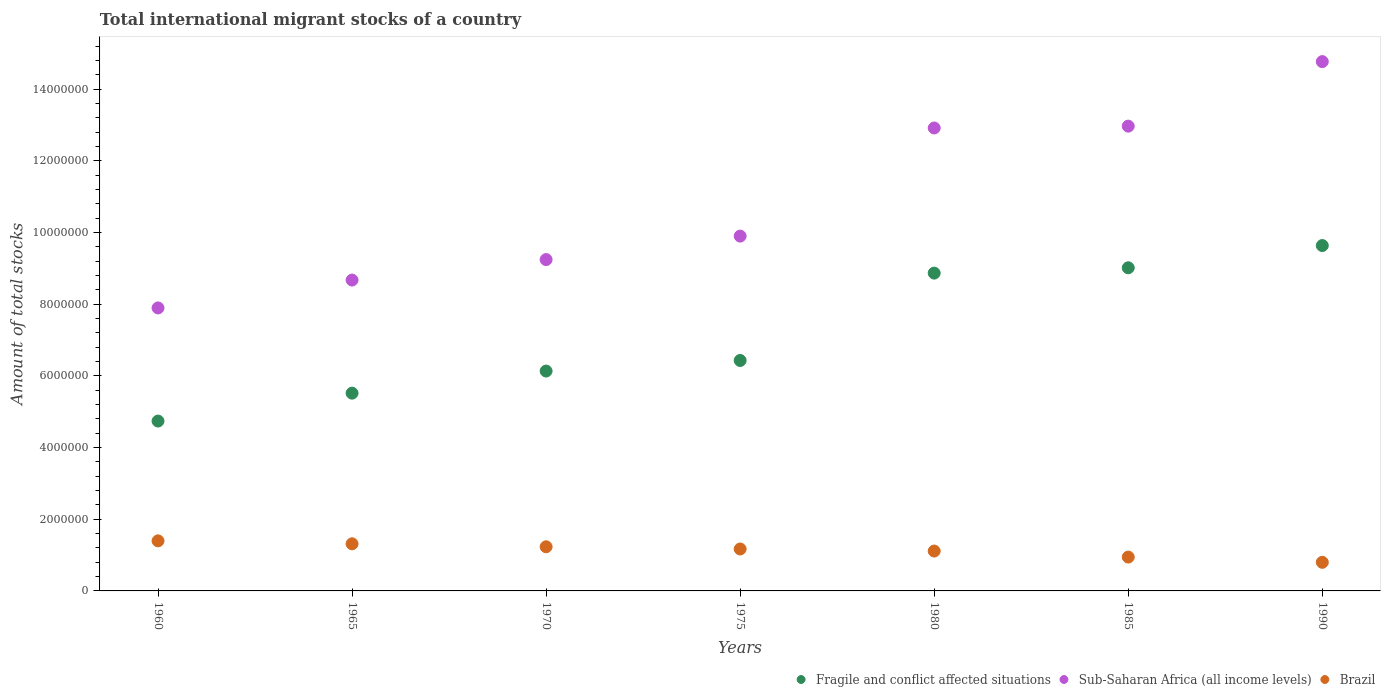How many different coloured dotlines are there?
Provide a short and direct response. 3. Is the number of dotlines equal to the number of legend labels?
Give a very brief answer. Yes. What is the amount of total stocks in in Sub-Saharan Africa (all income levels) in 1975?
Offer a terse response. 9.90e+06. Across all years, what is the maximum amount of total stocks in in Brazil?
Make the answer very short. 1.40e+06. Across all years, what is the minimum amount of total stocks in in Brazil?
Your response must be concise. 7.99e+05. What is the total amount of total stocks in in Brazil in the graph?
Your answer should be very brief. 7.97e+06. What is the difference between the amount of total stocks in in Sub-Saharan Africa (all income levels) in 1970 and that in 1985?
Your answer should be compact. -3.72e+06. What is the difference between the amount of total stocks in in Fragile and conflict affected situations in 1985 and the amount of total stocks in in Sub-Saharan Africa (all income levels) in 1960?
Ensure brevity in your answer.  1.12e+06. What is the average amount of total stocks in in Sub-Saharan Africa (all income levels) per year?
Provide a short and direct response. 1.09e+07. In the year 1990, what is the difference between the amount of total stocks in in Fragile and conflict affected situations and amount of total stocks in in Brazil?
Provide a succinct answer. 8.84e+06. What is the ratio of the amount of total stocks in in Brazil in 1960 to that in 1980?
Your response must be concise. 1.26. What is the difference between the highest and the second highest amount of total stocks in in Brazil?
Offer a very short reply. 8.22e+04. What is the difference between the highest and the lowest amount of total stocks in in Sub-Saharan Africa (all income levels)?
Offer a terse response. 6.87e+06. In how many years, is the amount of total stocks in in Fragile and conflict affected situations greater than the average amount of total stocks in in Fragile and conflict affected situations taken over all years?
Keep it short and to the point. 3. Does the amount of total stocks in in Sub-Saharan Africa (all income levels) monotonically increase over the years?
Offer a terse response. Yes. Is the amount of total stocks in in Sub-Saharan Africa (all income levels) strictly less than the amount of total stocks in in Fragile and conflict affected situations over the years?
Make the answer very short. No. What is the difference between two consecutive major ticks on the Y-axis?
Your answer should be compact. 2.00e+06. Does the graph contain any zero values?
Offer a terse response. No. Does the graph contain grids?
Your answer should be compact. No. Where does the legend appear in the graph?
Ensure brevity in your answer.  Bottom right. How many legend labels are there?
Your answer should be very brief. 3. What is the title of the graph?
Your answer should be very brief. Total international migrant stocks of a country. Does "Kosovo" appear as one of the legend labels in the graph?
Provide a short and direct response. No. What is the label or title of the Y-axis?
Provide a short and direct response. Amount of total stocks. What is the Amount of total stocks of Fragile and conflict affected situations in 1960?
Your answer should be very brief. 4.74e+06. What is the Amount of total stocks in Sub-Saharan Africa (all income levels) in 1960?
Provide a succinct answer. 7.90e+06. What is the Amount of total stocks in Brazil in 1960?
Your answer should be compact. 1.40e+06. What is the Amount of total stocks in Fragile and conflict affected situations in 1965?
Your answer should be very brief. 5.52e+06. What is the Amount of total stocks of Sub-Saharan Africa (all income levels) in 1965?
Provide a succinct answer. 8.68e+06. What is the Amount of total stocks of Brazil in 1965?
Your response must be concise. 1.31e+06. What is the Amount of total stocks in Fragile and conflict affected situations in 1970?
Offer a terse response. 6.14e+06. What is the Amount of total stocks of Sub-Saharan Africa (all income levels) in 1970?
Offer a very short reply. 9.25e+06. What is the Amount of total stocks of Brazil in 1970?
Your answer should be very brief. 1.23e+06. What is the Amount of total stocks of Fragile and conflict affected situations in 1975?
Ensure brevity in your answer.  6.43e+06. What is the Amount of total stocks of Sub-Saharan Africa (all income levels) in 1975?
Offer a very short reply. 9.90e+06. What is the Amount of total stocks in Brazil in 1975?
Your answer should be compact. 1.17e+06. What is the Amount of total stocks in Fragile and conflict affected situations in 1980?
Provide a short and direct response. 8.87e+06. What is the Amount of total stocks in Sub-Saharan Africa (all income levels) in 1980?
Make the answer very short. 1.29e+07. What is the Amount of total stocks in Brazil in 1980?
Offer a very short reply. 1.11e+06. What is the Amount of total stocks in Fragile and conflict affected situations in 1985?
Provide a succinct answer. 9.02e+06. What is the Amount of total stocks of Sub-Saharan Africa (all income levels) in 1985?
Ensure brevity in your answer.  1.30e+07. What is the Amount of total stocks of Brazil in 1985?
Ensure brevity in your answer.  9.45e+05. What is the Amount of total stocks of Fragile and conflict affected situations in 1990?
Offer a very short reply. 9.64e+06. What is the Amount of total stocks in Sub-Saharan Africa (all income levels) in 1990?
Your response must be concise. 1.48e+07. What is the Amount of total stocks in Brazil in 1990?
Ensure brevity in your answer.  7.99e+05. Across all years, what is the maximum Amount of total stocks of Fragile and conflict affected situations?
Provide a succinct answer. 9.64e+06. Across all years, what is the maximum Amount of total stocks in Sub-Saharan Africa (all income levels)?
Your response must be concise. 1.48e+07. Across all years, what is the maximum Amount of total stocks in Brazil?
Offer a very short reply. 1.40e+06. Across all years, what is the minimum Amount of total stocks of Fragile and conflict affected situations?
Ensure brevity in your answer.  4.74e+06. Across all years, what is the minimum Amount of total stocks in Sub-Saharan Africa (all income levels)?
Ensure brevity in your answer.  7.90e+06. Across all years, what is the minimum Amount of total stocks in Brazil?
Provide a succinct answer. 7.99e+05. What is the total Amount of total stocks in Fragile and conflict affected situations in the graph?
Ensure brevity in your answer.  5.04e+07. What is the total Amount of total stocks in Sub-Saharan Africa (all income levels) in the graph?
Give a very brief answer. 7.64e+07. What is the total Amount of total stocks of Brazil in the graph?
Give a very brief answer. 7.97e+06. What is the difference between the Amount of total stocks in Fragile and conflict affected situations in 1960 and that in 1965?
Your answer should be compact. -7.79e+05. What is the difference between the Amount of total stocks in Sub-Saharan Africa (all income levels) in 1960 and that in 1965?
Provide a short and direct response. -7.78e+05. What is the difference between the Amount of total stocks in Brazil in 1960 and that in 1965?
Your answer should be compact. 8.22e+04. What is the difference between the Amount of total stocks of Fragile and conflict affected situations in 1960 and that in 1970?
Keep it short and to the point. -1.40e+06. What is the difference between the Amount of total stocks of Sub-Saharan Africa (all income levels) in 1960 and that in 1970?
Your answer should be very brief. -1.35e+06. What is the difference between the Amount of total stocks in Brazil in 1960 and that in 1970?
Your answer should be compact. 1.65e+05. What is the difference between the Amount of total stocks of Fragile and conflict affected situations in 1960 and that in 1975?
Give a very brief answer. -1.69e+06. What is the difference between the Amount of total stocks of Sub-Saharan Africa (all income levels) in 1960 and that in 1975?
Ensure brevity in your answer.  -2.00e+06. What is the difference between the Amount of total stocks of Brazil in 1960 and that in 1975?
Offer a very short reply. 2.27e+05. What is the difference between the Amount of total stocks in Fragile and conflict affected situations in 1960 and that in 1980?
Your answer should be compact. -4.13e+06. What is the difference between the Amount of total stocks in Sub-Saharan Africa (all income levels) in 1960 and that in 1980?
Offer a terse response. -5.02e+06. What is the difference between the Amount of total stocks of Brazil in 1960 and that in 1980?
Provide a short and direct response. 2.84e+05. What is the difference between the Amount of total stocks of Fragile and conflict affected situations in 1960 and that in 1985?
Provide a succinct answer. -4.28e+06. What is the difference between the Amount of total stocks of Sub-Saharan Africa (all income levels) in 1960 and that in 1985?
Provide a succinct answer. -5.07e+06. What is the difference between the Amount of total stocks of Brazil in 1960 and that in 1985?
Offer a very short reply. 4.53e+05. What is the difference between the Amount of total stocks of Fragile and conflict affected situations in 1960 and that in 1990?
Your answer should be compact. -4.90e+06. What is the difference between the Amount of total stocks in Sub-Saharan Africa (all income levels) in 1960 and that in 1990?
Make the answer very short. -6.87e+06. What is the difference between the Amount of total stocks in Brazil in 1960 and that in 1990?
Provide a succinct answer. 5.99e+05. What is the difference between the Amount of total stocks in Fragile and conflict affected situations in 1965 and that in 1970?
Keep it short and to the point. -6.17e+05. What is the difference between the Amount of total stocks of Sub-Saharan Africa (all income levels) in 1965 and that in 1970?
Your response must be concise. -5.72e+05. What is the difference between the Amount of total stocks in Brazil in 1965 and that in 1970?
Make the answer very short. 8.31e+04. What is the difference between the Amount of total stocks of Fragile and conflict affected situations in 1965 and that in 1975?
Your answer should be very brief. -9.12e+05. What is the difference between the Amount of total stocks in Sub-Saharan Africa (all income levels) in 1965 and that in 1975?
Provide a short and direct response. -1.23e+06. What is the difference between the Amount of total stocks in Brazil in 1965 and that in 1975?
Ensure brevity in your answer.  1.44e+05. What is the difference between the Amount of total stocks of Fragile and conflict affected situations in 1965 and that in 1980?
Keep it short and to the point. -3.35e+06. What is the difference between the Amount of total stocks in Sub-Saharan Africa (all income levels) in 1965 and that in 1980?
Provide a succinct answer. -4.24e+06. What is the difference between the Amount of total stocks in Brazil in 1965 and that in 1980?
Keep it short and to the point. 2.02e+05. What is the difference between the Amount of total stocks in Fragile and conflict affected situations in 1965 and that in 1985?
Provide a succinct answer. -3.50e+06. What is the difference between the Amount of total stocks in Sub-Saharan Africa (all income levels) in 1965 and that in 1985?
Your answer should be very brief. -4.30e+06. What is the difference between the Amount of total stocks in Brazil in 1965 and that in 1985?
Offer a terse response. 3.70e+05. What is the difference between the Amount of total stocks in Fragile and conflict affected situations in 1965 and that in 1990?
Offer a very short reply. -4.12e+06. What is the difference between the Amount of total stocks of Sub-Saharan Africa (all income levels) in 1965 and that in 1990?
Your response must be concise. -6.10e+06. What is the difference between the Amount of total stocks in Brazil in 1965 and that in 1990?
Your answer should be compact. 5.16e+05. What is the difference between the Amount of total stocks of Fragile and conflict affected situations in 1970 and that in 1975?
Your answer should be compact. -2.95e+05. What is the difference between the Amount of total stocks of Sub-Saharan Africa (all income levels) in 1970 and that in 1975?
Keep it short and to the point. -6.55e+05. What is the difference between the Amount of total stocks of Brazil in 1970 and that in 1975?
Your answer should be compact. 6.13e+04. What is the difference between the Amount of total stocks of Fragile and conflict affected situations in 1970 and that in 1980?
Keep it short and to the point. -2.73e+06. What is the difference between the Amount of total stocks in Sub-Saharan Africa (all income levels) in 1970 and that in 1980?
Your answer should be compact. -3.67e+06. What is the difference between the Amount of total stocks in Brazil in 1970 and that in 1980?
Provide a short and direct response. 1.19e+05. What is the difference between the Amount of total stocks in Fragile and conflict affected situations in 1970 and that in 1985?
Offer a terse response. -2.88e+06. What is the difference between the Amount of total stocks of Sub-Saharan Africa (all income levels) in 1970 and that in 1985?
Ensure brevity in your answer.  -3.72e+06. What is the difference between the Amount of total stocks in Brazil in 1970 and that in 1985?
Offer a terse response. 2.87e+05. What is the difference between the Amount of total stocks in Fragile and conflict affected situations in 1970 and that in 1990?
Provide a short and direct response. -3.50e+06. What is the difference between the Amount of total stocks in Sub-Saharan Africa (all income levels) in 1970 and that in 1990?
Offer a very short reply. -5.52e+06. What is the difference between the Amount of total stocks of Brazil in 1970 and that in 1990?
Give a very brief answer. 4.33e+05. What is the difference between the Amount of total stocks in Fragile and conflict affected situations in 1975 and that in 1980?
Provide a succinct answer. -2.44e+06. What is the difference between the Amount of total stocks of Sub-Saharan Africa (all income levels) in 1975 and that in 1980?
Keep it short and to the point. -3.02e+06. What is the difference between the Amount of total stocks of Brazil in 1975 and that in 1980?
Keep it short and to the point. 5.77e+04. What is the difference between the Amount of total stocks of Fragile and conflict affected situations in 1975 and that in 1985?
Make the answer very short. -2.59e+06. What is the difference between the Amount of total stocks in Sub-Saharan Africa (all income levels) in 1975 and that in 1985?
Your response must be concise. -3.07e+06. What is the difference between the Amount of total stocks of Brazil in 1975 and that in 1985?
Make the answer very short. 2.26e+05. What is the difference between the Amount of total stocks in Fragile and conflict affected situations in 1975 and that in 1990?
Keep it short and to the point. -3.21e+06. What is the difference between the Amount of total stocks of Sub-Saharan Africa (all income levels) in 1975 and that in 1990?
Ensure brevity in your answer.  -4.87e+06. What is the difference between the Amount of total stocks in Brazil in 1975 and that in 1990?
Make the answer very short. 3.72e+05. What is the difference between the Amount of total stocks in Fragile and conflict affected situations in 1980 and that in 1985?
Offer a very short reply. -1.49e+05. What is the difference between the Amount of total stocks in Sub-Saharan Africa (all income levels) in 1980 and that in 1985?
Offer a terse response. -5.11e+04. What is the difference between the Amount of total stocks in Brazil in 1980 and that in 1985?
Give a very brief answer. 1.68e+05. What is the difference between the Amount of total stocks in Fragile and conflict affected situations in 1980 and that in 1990?
Your answer should be compact. -7.69e+05. What is the difference between the Amount of total stocks of Sub-Saharan Africa (all income levels) in 1980 and that in 1990?
Give a very brief answer. -1.85e+06. What is the difference between the Amount of total stocks of Brazil in 1980 and that in 1990?
Your response must be concise. 3.14e+05. What is the difference between the Amount of total stocks of Fragile and conflict affected situations in 1985 and that in 1990?
Your answer should be very brief. -6.21e+05. What is the difference between the Amount of total stocks of Sub-Saharan Africa (all income levels) in 1985 and that in 1990?
Offer a terse response. -1.80e+06. What is the difference between the Amount of total stocks of Brazil in 1985 and that in 1990?
Provide a short and direct response. 1.46e+05. What is the difference between the Amount of total stocks of Fragile and conflict affected situations in 1960 and the Amount of total stocks of Sub-Saharan Africa (all income levels) in 1965?
Provide a succinct answer. -3.94e+06. What is the difference between the Amount of total stocks of Fragile and conflict affected situations in 1960 and the Amount of total stocks of Brazil in 1965?
Your answer should be very brief. 3.43e+06. What is the difference between the Amount of total stocks in Sub-Saharan Africa (all income levels) in 1960 and the Amount of total stocks in Brazil in 1965?
Make the answer very short. 6.58e+06. What is the difference between the Amount of total stocks of Fragile and conflict affected situations in 1960 and the Amount of total stocks of Sub-Saharan Africa (all income levels) in 1970?
Keep it short and to the point. -4.51e+06. What is the difference between the Amount of total stocks in Fragile and conflict affected situations in 1960 and the Amount of total stocks in Brazil in 1970?
Make the answer very short. 3.51e+06. What is the difference between the Amount of total stocks of Sub-Saharan Africa (all income levels) in 1960 and the Amount of total stocks of Brazil in 1970?
Your answer should be compact. 6.67e+06. What is the difference between the Amount of total stocks of Fragile and conflict affected situations in 1960 and the Amount of total stocks of Sub-Saharan Africa (all income levels) in 1975?
Your response must be concise. -5.16e+06. What is the difference between the Amount of total stocks of Fragile and conflict affected situations in 1960 and the Amount of total stocks of Brazil in 1975?
Give a very brief answer. 3.57e+06. What is the difference between the Amount of total stocks of Sub-Saharan Africa (all income levels) in 1960 and the Amount of total stocks of Brazil in 1975?
Provide a short and direct response. 6.73e+06. What is the difference between the Amount of total stocks in Fragile and conflict affected situations in 1960 and the Amount of total stocks in Sub-Saharan Africa (all income levels) in 1980?
Provide a short and direct response. -8.18e+06. What is the difference between the Amount of total stocks in Fragile and conflict affected situations in 1960 and the Amount of total stocks in Brazil in 1980?
Offer a very short reply. 3.63e+06. What is the difference between the Amount of total stocks of Sub-Saharan Africa (all income levels) in 1960 and the Amount of total stocks of Brazil in 1980?
Provide a succinct answer. 6.78e+06. What is the difference between the Amount of total stocks in Fragile and conflict affected situations in 1960 and the Amount of total stocks in Sub-Saharan Africa (all income levels) in 1985?
Provide a short and direct response. -8.23e+06. What is the difference between the Amount of total stocks of Fragile and conflict affected situations in 1960 and the Amount of total stocks of Brazil in 1985?
Ensure brevity in your answer.  3.80e+06. What is the difference between the Amount of total stocks of Sub-Saharan Africa (all income levels) in 1960 and the Amount of total stocks of Brazil in 1985?
Provide a short and direct response. 6.95e+06. What is the difference between the Amount of total stocks in Fragile and conflict affected situations in 1960 and the Amount of total stocks in Sub-Saharan Africa (all income levels) in 1990?
Offer a very short reply. -1.00e+07. What is the difference between the Amount of total stocks of Fragile and conflict affected situations in 1960 and the Amount of total stocks of Brazil in 1990?
Make the answer very short. 3.94e+06. What is the difference between the Amount of total stocks of Sub-Saharan Africa (all income levels) in 1960 and the Amount of total stocks of Brazil in 1990?
Offer a very short reply. 7.10e+06. What is the difference between the Amount of total stocks in Fragile and conflict affected situations in 1965 and the Amount of total stocks in Sub-Saharan Africa (all income levels) in 1970?
Your answer should be very brief. -3.73e+06. What is the difference between the Amount of total stocks of Fragile and conflict affected situations in 1965 and the Amount of total stocks of Brazil in 1970?
Ensure brevity in your answer.  4.29e+06. What is the difference between the Amount of total stocks of Sub-Saharan Africa (all income levels) in 1965 and the Amount of total stocks of Brazil in 1970?
Keep it short and to the point. 7.44e+06. What is the difference between the Amount of total stocks of Fragile and conflict affected situations in 1965 and the Amount of total stocks of Sub-Saharan Africa (all income levels) in 1975?
Your answer should be very brief. -4.38e+06. What is the difference between the Amount of total stocks in Fragile and conflict affected situations in 1965 and the Amount of total stocks in Brazil in 1975?
Keep it short and to the point. 4.35e+06. What is the difference between the Amount of total stocks of Sub-Saharan Africa (all income levels) in 1965 and the Amount of total stocks of Brazil in 1975?
Provide a succinct answer. 7.50e+06. What is the difference between the Amount of total stocks of Fragile and conflict affected situations in 1965 and the Amount of total stocks of Sub-Saharan Africa (all income levels) in 1980?
Your response must be concise. -7.40e+06. What is the difference between the Amount of total stocks of Fragile and conflict affected situations in 1965 and the Amount of total stocks of Brazil in 1980?
Your response must be concise. 4.41e+06. What is the difference between the Amount of total stocks of Sub-Saharan Africa (all income levels) in 1965 and the Amount of total stocks of Brazil in 1980?
Give a very brief answer. 7.56e+06. What is the difference between the Amount of total stocks of Fragile and conflict affected situations in 1965 and the Amount of total stocks of Sub-Saharan Africa (all income levels) in 1985?
Your answer should be very brief. -7.45e+06. What is the difference between the Amount of total stocks of Fragile and conflict affected situations in 1965 and the Amount of total stocks of Brazil in 1985?
Give a very brief answer. 4.57e+06. What is the difference between the Amount of total stocks of Sub-Saharan Africa (all income levels) in 1965 and the Amount of total stocks of Brazil in 1985?
Give a very brief answer. 7.73e+06. What is the difference between the Amount of total stocks of Fragile and conflict affected situations in 1965 and the Amount of total stocks of Sub-Saharan Africa (all income levels) in 1990?
Provide a short and direct response. -9.25e+06. What is the difference between the Amount of total stocks in Fragile and conflict affected situations in 1965 and the Amount of total stocks in Brazil in 1990?
Ensure brevity in your answer.  4.72e+06. What is the difference between the Amount of total stocks in Sub-Saharan Africa (all income levels) in 1965 and the Amount of total stocks in Brazil in 1990?
Provide a short and direct response. 7.88e+06. What is the difference between the Amount of total stocks of Fragile and conflict affected situations in 1970 and the Amount of total stocks of Sub-Saharan Africa (all income levels) in 1975?
Your answer should be very brief. -3.77e+06. What is the difference between the Amount of total stocks of Fragile and conflict affected situations in 1970 and the Amount of total stocks of Brazil in 1975?
Your answer should be very brief. 4.97e+06. What is the difference between the Amount of total stocks in Sub-Saharan Africa (all income levels) in 1970 and the Amount of total stocks in Brazil in 1975?
Your answer should be compact. 8.08e+06. What is the difference between the Amount of total stocks of Fragile and conflict affected situations in 1970 and the Amount of total stocks of Sub-Saharan Africa (all income levels) in 1980?
Make the answer very short. -6.78e+06. What is the difference between the Amount of total stocks of Fragile and conflict affected situations in 1970 and the Amount of total stocks of Brazil in 1980?
Make the answer very short. 5.02e+06. What is the difference between the Amount of total stocks in Sub-Saharan Africa (all income levels) in 1970 and the Amount of total stocks in Brazil in 1980?
Give a very brief answer. 8.13e+06. What is the difference between the Amount of total stocks of Fragile and conflict affected situations in 1970 and the Amount of total stocks of Sub-Saharan Africa (all income levels) in 1985?
Keep it short and to the point. -6.83e+06. What is the difference between the Amount of total stocks of Fragile and conflict affected situations in 1970 and the Amount of total stocks of Brazil in 1985?
Your answer should be very brief. 5.19e+06. What is the difference between the Amount of total stocks in Sub-Saharan Africa (all income levels) in 1970 and the Amount of total stocks in Brazil in 1985?
Ensure brevity in your answer.  8.30e+06. What is the difference between the Amount of total stocks of Fragile and conflict affected situations in 1970 and the Amount of total stocks of Sub-Saharan Africa (all income levels) in 1990?
Offer a very short reply. -8.64e+06. What is the difference between the Amount of total stocks in Fragile and conflict affected situations in 1970 and the Amount of total stocks in Brazil in 1990?
Offer a terse response. 5.34e+06. What is the difference between the Amount of total stocks of Sub-Saharan Africa (all income levels) in 1970 and the Amount of total stocks of Brazil in 1990?
Keep it short and to the point. 8.45e+06. What is the difference between the Amount of total stocks in Fragile and conflict affected situations in 1975 and the Amount of total stocks in Sub-Saharan Africa (all income levels) in 1980?
Keep it short and to the point. -6.49e+06. What is the difference between the Amount of total stocks in Fragile and conflict affected situations in 1975 and the Amount of total stocks in Brazil in 1980?
Provide a succinct answer. 5.32e+06. What is the difference between the Amount of total stocks in Sub-Saharan Africa (all income levels) in 1975 and the Amount of total stocks in Brazil in 1980?
Ensure brevity in your answer.  8.79e+06. What is the difference between the Amount of total stocks in Fragile and conflict affected situations in 1975 and the Amount of total stocks in Sub-Saharan Africa (all income levels) in 1985?
Offer a very short reply. -6.54e+06. What is the difference between the Amount of total stocks of Fragile and conflict affected situations in 1975 and the Amount of total stocks of Brazil in 1985?
Keep it short and to the point. 5.49e+06. What is the difference between the Amount of total stocks in Sub-Saharan Africa (all income levels) in 1975 and the Amount of total stocks in Brazil in 1985?
Ensure brevity in your answer.  8.96e+06. What is the difference between the Amount of total stocks in Fragile and conflict affected situations in 1975 and the Amount of total stocks in Sub-Saharan Africa (all income levels) in 1990?
Your answer should be compact. -8.34e+06. What is the difference between the Amount of total stocks of Fragile and conflict affected situations in 1975 and the Amount of total stocks of Brazil in 1990?
Provide a short and direct response. 5.63e+06. What is the difference between the Amount of total stocks in Sub-Saharan Africa (all income levels) in 1975 and the Amount of total stocks in Brazil in 1990?
Give a very brief answer. 9.10e+06. What is the difference between the Amount of total stocks of Fragile and conflict affected situations in 1980 and the Amount of total stocks of Sub-Saharan Africa (all income levels) in 1985?
Provide a short and direct response. -4.10e+06. What is the difference between the Amount of total stocks in Fragile and conflict affected situations in 1980 and the Amount of total stocks in Brazil in 1985?
Make the answer very short. 7.92e+06. What is the difference between the Amount of total stocks of Sub-Saharan Africa (all income levels) in 1980 and the Amount of total stocks of Brazil in 1985?
Make the answer very short. 1.20e+07. What is the difference between the Amount of total stocks of Fragile and conflict affected situations in 1980 and the Amount of total stocks of Sub-Saharan Africa (all income levels) in 1990?
Give a very brief answer. -5.90e+06. What is the difference between the Amount of total stocks in Fragile and conflict affected situations in 1980 and the Amount of total stocks in Brazil in 1990?
Ensure brevity in your answer.  8.07e+06. What is the difference between the Amount of total stocks in Sub-Saharan Africa (all income levels) in 1980 and the Amount of total stocks in Brazil in 1990?
Offer a terse response. 1.21e+07. What is the difference between the Amount of total stocks in Fragile and conflict affected situations in 1985 and the Amount of total stocks in Sub-Saharan Africa (all income levels) in 1990?
Your response must be concise. -5.75e+06. What is the difference between the Amount of total stocks in Fragile and conflict affected situations in 1985 and the Amount of total stocks in Brazil in 1990?
Ensure brevity in your answer.  8.22e+06. What is the difference between the Amount of total stocks of Sub-Saharan Africa (all income levels) in 1985 and the Amount of total stocks of Brazil in 1990?
Give a very brief answer. 1.22e+07. What is the average Amount of total stocks of Fragile and conflict affected situations per year?
Provide a succinct answer. 7.19e+06. What is the average Amount of total stocks of Sub-Saharan Africa (all income levels) per year?
Ensure brevity in your answer.  1.09e+07. What is the average Amount of total stocks of Brazil per year?
Provide a succinct answer. 1.14e+06. In the year 1960, what is the difference between the Amount of total stocks in Fragile and conflict affected situations and Amount of total stocks in Sub-Saharan Africa (all income levels)?
Offer a terse response. -3.16e+06. In the year 1960, what is the difference between the Amount of total stocks of Fragile and conflict affected situations and Amount of total stocks of Brazil?
Your answer should be very brief. 3.34e+06. In the year 1960, what is the difference between the Amount of total stocks of Sub-Saharan Africa (all income levels) and Amount of total stocks of Brazil?
Your answer should be compact. 6.50e+06. In the year 1965, what is the difference between the Amount of total stocks in Fragile and conflict affected situations and Amount of total stocks in Sub-Saharan Africa (all income levels)?
Your answer should be compact. -3.16e+06. In the year 1965, what is the difference between the Amount of total stocks of Fragile and conflict affected situations and Amount of total stocks of Brazil?
Provide a succinct answer. 4.20e+06. In the year 1965, what is the difference between the Amount of total stocks of Sub-Saharan Africa (all income levels) and Amount of total stocks of Brazil?
Provide a short and direct response. 7.36e+06. In the year 1970, what is the difference between the Amount of total stocks in Fragile and conflict affected situations and Amount of total stocks in Sub-Saharan Africa (all income levels)?
Offer a terse response. -3.11e+06. In the year 1970, what is the difference between the Amount of total stocks in Fragile and conflict affected situations and Amount of total stocks in Brazil?
Make the answer very short. 4.90e+06. In the year 1970, what is the difference between the Amount of total stocks in Sub-Saharan Africa (all income levels) and Amount of total stocks in Brazil?
Offer a terse response. 8.01e+06. In the year 1975, what is the difference between the Amount of total stocks of Fragile and conflict affected situations and Amount of total stocks of Sub-Saharan Africa (all income levels)?
Make the answer very short. -3.47e+06. In the year 1975, what is the difference between the Amount of total stocks in Fragile and conflict affected situations and Amount of total stocks in Brazil?
Give a very brief answer. 5.26e+06. In the year 1975, what is the difference between the Amount of total stocks of Sub-Saharan Africa (all income levels) and Amount of total stocks of Brazil?
Make the answer very short. 8.73e+06. In the year 1980, what is the difference between the Amount of total stocks in Fragile and conflict affected situations and Amount of total stocks in Sub-Saharan Africa (all income levels)?
Provide a short and direct response. -4.05e+06. In the year 1980, what is the difference between the Amount of total stocks in Fragile and conflict affected situations and Amount of total stocks in Brazil?
Your answer should be very brief. 7.76e+06. In the year 1980, what is the difference between the Amount of total stocks in Sub-Saharan Africa (all income levels) and Amount of total stocks in Brazil?
Offer a very short reply. 1.18e+07. In the year 1985, what is the difference between the Amount of total stocks in Fragile and conflict affected situations and Amount of total stocks in Sub-Saharan Africa (all income levels)?
Give a very brief answer. -3.95e+06. In the year 1985, what is the difference between the Amount of total stocks in Fragile and conflict affected situations and Amount of total stocks in Brazil?
Ensure brevity in your answer.  8.07e+06. In the year 1985, what is the difference between the Amount of total stocks in Sub-Saharan Africa (all income levels) and Amount of total stocks in Brazil?
Keep it short and to the point. 1.20e+07. In the year 1990, what is the difference between the Amount of total stocks of Fragile and conflict affected situations and Amount of total stocks of Sub-Saharan Africa (all income levels)?
Your answer should be compact. -5.13e+06. In the year 1990, what is the difference between the Amount of total stocks in Fragile and conflict affected situations and Amount of total stocks in Brazil?
Offer a very short reply. 8.84e+06. In the year 1990, what is the difference between the Amount of total stocks of Sub-Saharan Africa (all income levels) and Amount of total stocks of Brazil?
Make the answer very short. 1.40e+07. What is the ratio of the Amount of total stocks in Fragile and conflict affected situations in 1960 to that in 1965?
Make the answer very short. 0.86. What is the ratio of the Amount of total stocks in Sub-Saharan Africa (all income levels) in 1960 to that in 1965?
Give a very brief answer. 0.91. What is the ratio of the Amount of total stocks in Brazil in 1960 to that in 1965?
Offer a terse response. 1.06. What is the ratio of the Amount of total stocks of Fragile and conflict affected situations in 1960 to that in 1970?
Keep it short and to the point. 0.77. What is the ratio of the Amount of total stocks of Sub-Saharan Africa (all income levels) in 1960 to that in 1970?
Give a very brief answer. 0.85. What is the ratio of the Amount of total stocks of Brazil in 1960 to that in 1970?
Provide a short and direct response. 1.13. What is the ratio of the Amount of total stocks in Fragile and conflict affected situations in 1960 to that in 1975?
Your response must be concise. 0.74. What is the ratio of the Amount of total stocks of Sub-Saharan Africa (all income levels) in 1960 to that in 1975?
Your answer should be very brief. 0.8. What is the ratio of the Amount of total stocks of Brazil in 1960 to that in 1975?
Your response must be concise. 1.19. What is the ratio of the Amount of total stocks of Fragile and conflict affected situations in 1960 to that in 1980?
Your answer should be compact. 0.53. What is the ratio of the Amount of total stocks of Sub-Saharan Africa (all income levels) in 1960 to that in 1980?
Make the answer very short. 0.61. What is the ratio of the Amount of total stocks in Brazil in 1960 to that in 1980?
Provide a short and direct response. 1.26. What is the ratio of the Amount of total stocks in Fragile and conflict affected situations in 1960 to that in 1985?
Keep it short and to the point. 0.53. What is the ratio of the Amount of total stocks of Sub-Saharan Africa (all income levels) in 1960 to that in 1985?
Provide a short and direct response. 0.61. What is the ratio of the Amount of total stocks in Brazil in 1960 to that in 1985?
Your response must be concise. 1.48. What is the ratio of the Amount of total stocks in Fragile and conflict affected situations in 1960 to that in 1990?
Ensure brevity in your answer.  0.49. What is the ratio of the Amount of total stocks in Sub-Saharan Africa (all income levels) in 1960 to that in 1990?
Keep it short and to the point. 0.53. What is the ratio of the Amount of total stocks of Brazil in 1960 to that in 1990?
Your answer should be compact. 1.75. What is the ratio of the Amount of total stocks in Fragile and conflict affected situations in 1965 to that in 1970?
Offer a very short reply. 0.9. What is the ratio of the Amount of total stocks of Sub-Saharan Africa (all income levels) in 1965 to that in 1970?
Your answer should be very brief. 0.94. What is the ratio of the Amount of total stocks in Brazil in 1965 to that in 1970?
Give a very brief answer. 1.07. What is the ratio of the Amount of total stocks in Fragile and conflict affected situations in 1965 to that in 1975?
Provide a short and direct response. 0.86. What is the ratio of the Amount of total stocks of Sub-Saharan Africa (all income levels) in 1965 to that in 1975?
Offer a terse response. 0.88. What is the ratio of the Amount of total stocks of Brazil in 1965 to that in 1975?
Your response must be concise. 1.12. What is the ratio of the Amount of total stocks of Fragile and conflict affected situations in 1965 to that in 1980?
Make the answer very short. 0.62. What is the ratio of the Amount of total stocks of Sub-Saharan Africa (all income levels) in 1965 to that in 1980?
Provide a short and direct response. 0.67. What is the ratio of the Amount of total stocks in Brazil in 1965 to that in 1980?
Give a very brief answer. 1.18. What is the ratio of the Amount of total stocks of Fragile and conflict affected situations in 1965 to that in 1985?
Your answer should be compact. 0.61. What is the ratio of the Amount of total stocks of Sub-Saharan Africa (all income levels) in 1965 to that in 1985?
Offer a terse response. 0.67. What is the ratio of the Amount of total stocks in Brazil in 1965 to that in 1985?
Keep it short and to the point. 1.39. What is the ratio of the Amount of total stocks of Fragile and conflict affected situations in 1965 to that in 1990?
Ensure brevity in your answer.  0.57. What is the ratio of the Amount of total stocks in Sub-Saharan Africa (all income levels) in 1965 to that in 1990?
Your response must be concise. 0.59. What is the ratio of the Amount of total stocks in Brazil in 1965 to that in 1990?
Give a very brief answer. 1.65. What is the ratio of the Amount of total stocks of Fragile and conflict affected situations in 1970 to that in 1975?
Ensure brevity in your answer.  0.95. What is the ratio of the Amount of total stocks in Sub-Saharan Africa (all income levels) in 1970 to that in 1975?
Keep it short and to the point. 0.93. What is the ratio of the Amount of total stocks of Brazil in 1970 to that in 1975?
Provide a succinct answer. 1.05. What is the ratio of the Amount of total stocks of Fragile and conflict affected situations in 1970 to that in 1980?
Offer a terse response. 0.69. What is the ratio of the Amount of total stocks in Sub-Saharan Africa (all income levels) in 1970 to that in 1980?
Offer a terse response. 0.72. What is the ratio of the Amount of total stocks of Brazil in 1970 to that in 1980?
Provide a short and direct response. 1.11. What is the ratio of the Amount of total stocks in Fragile and conflict affected situations in 1970 to that in 1985?
Your answer should be very brief. 0.68. What is the ratio of the Amount of total stocks in Sub-Saharan Africa (all income levels) in 1970 to that in 1985?
Give a very brief answer. 0.71. What is the ratio of the Amount of total stocks in Brazil in 1970 to that in 1985?
Your response must be concise. 1.3. What is the ratio of the Amount of total stocks of Fragile and conflict affected situations in 1970 to that in 1990?
Offer a terse response. 0.64. What is the ratio of the Amount of total stocks in Sub-Saharan Africa (all income levels) in 1970 to that in 1990?
Your answer should be very brief. 0.63. What is the ratio of the Amount of total stocks in Brazil in 1970 to that in 1990?
Provide a short and direct response. 1.54. What is the ratio of the Amount of total stocks in Fragile and conflict affected situations in 1975 to that in 1980?
Make the answer very short. 0.73. What is the ratio of the Amount of total stocks of Sub-Saharan Africa (all income levels) in 1975 to that in 1980?
Provide a succinct answer. 0.77. What is the ratio of the Amount of total stocks of Brazil in 1975 to that in 1980?
Your answer should be very brief. 1.05. What is the ratio of the Amount of total stocks in Fragile and conflict affected situations in 1975 to that in 1985?
Your answer should be very brief. 0.71. What is the ratio of the Amount of total stocks of Sub-Saharan Africa (all income levels) in 1975 to that in 1985?
Keep it short and to the point. 0.76. What is the ratio of the Amount of total stocks of Brazil in 1975 to that in 1985?
Provide a succinct answer. 1.24. What is the ratio of the Amount of total stocks in Fragile and conflict affected situations in 1975 to that in 1990?
Your answer should be compact. 0.67. What is the ratio of the Amount of total stocks of Sub-Saharan Africa (all income levels) in 1975 to that in 1990?
Provide a succinct answer. 0.67. What is the ratio of the Amount of total stocks in Brazil in 1975 to that in 1990?
Ensure brevity in your answer.  1.47. What is the ratio of the Amount of total stocks in Fragile and conflict affected situations in 1980 to that in 1985?
Your answer should be compact. 0.98. What is the ratio of the Amount of total stocks of Sub-Saharan Africa (all income levels) in 1980 to that in 1985?
Make the answer very short. 1. What is the ratio of the Amount of total stocks of Brazil in 1980 to that in 1985?
Provide a succinct answer. 1.18. What is the ratio of the Amount of total stocks of Fragile and conflict affected situations in 1980 to that in 1990?
Your answer should be very brief. 0.92. What is the ratio of the Amount of total stocks in Sub-Saharan Africa (all income levels) in 1980 to that in 1990?
Your answer should be compact. 0.87. What is the ratio of the Amount of total stocks of Brazil in 1980 to that in 1990?
Ensure brevity in your answer.  1.39. What is the ratio of the Amount of total stocks of Fragile and conflict affected situations in 1985 to that in 1990?
Your answer should be very brief. 0.94. What is the ratio of the Amount of total stocks of Sub-Saharan Africa (all income levels) in 1985 to that in 1990?
Provide a succinct answer. 0.88. What is the ratio of the Amount of total stocks of Brazil in 1985 to that in 1990?
Your answer should be very brief. 1.18. What is the difference between the highest and the second highest Amount of total stocks in Fragile and conflict affected situations?
Provide a succinct answer. 6.21e+05. What is the difference between the highest and the second highest Amount of total stocks of Sub-Saharan Africa (all income levels)?
Give a very brief answer. 1.80e+06. What is the difference between the highest and the second highest Amount of total stocks of Brazil?
Give a very brief answer. 8.22e+04. What is the difference between the highest and the lowest Amount of total stocks of Fragile and conflict affected situations?
Provide a short and direct response. 4.90e+06. What is the difference between the highest and the lowest Amount of total stocks of Sub-Saharan Africa (all income levels)?
Keep it short and to the point. 6.87e+06. What is the difference between the highest and the lowest Amount of total stocks of Brazil?
Your response must be concise. 5.99e+05. 